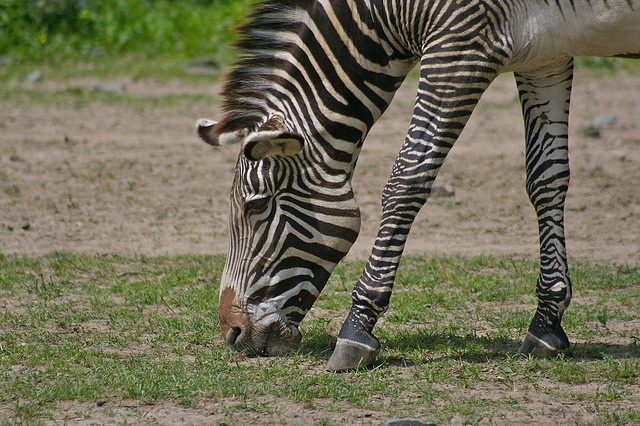Describe the objects in this image and their specific colors. I can see a zebra in darkgreen, black, gray, and darkgray tones in this image. 